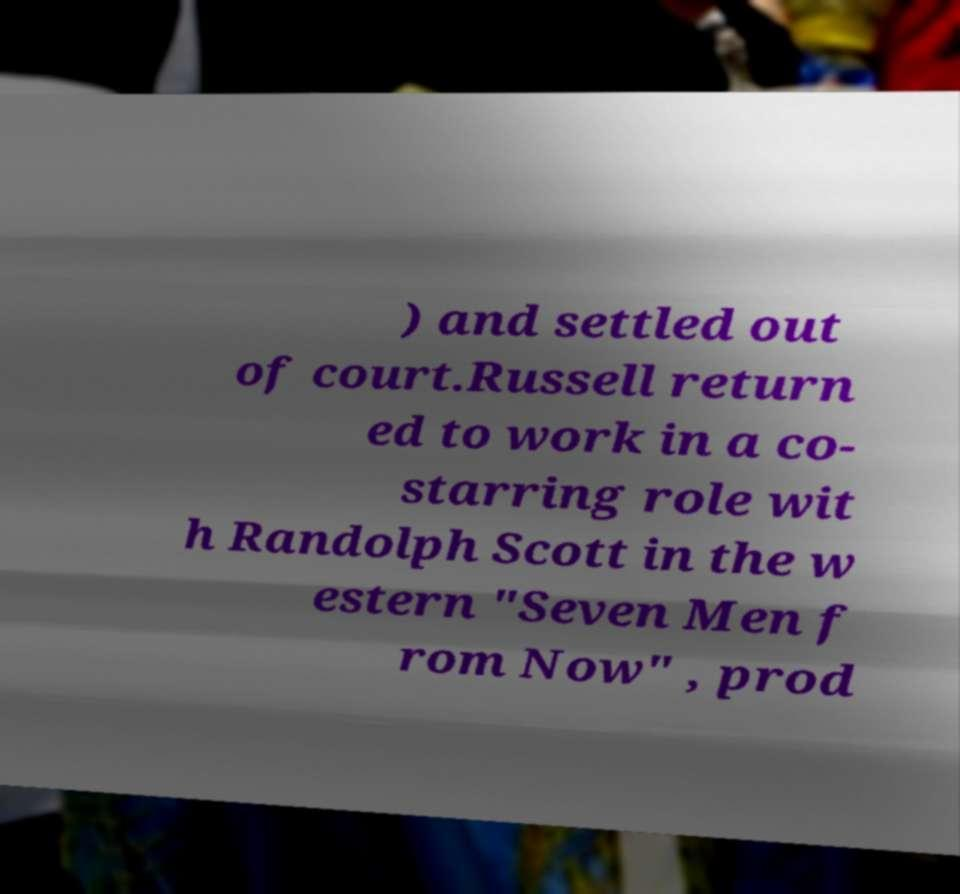Could you extract and type out the text from this image? ) and settled out of court.Russell return ed to work in a co- starring role wit h Randolph Scott in the w estern "Seven Men f rom Now" , prod 